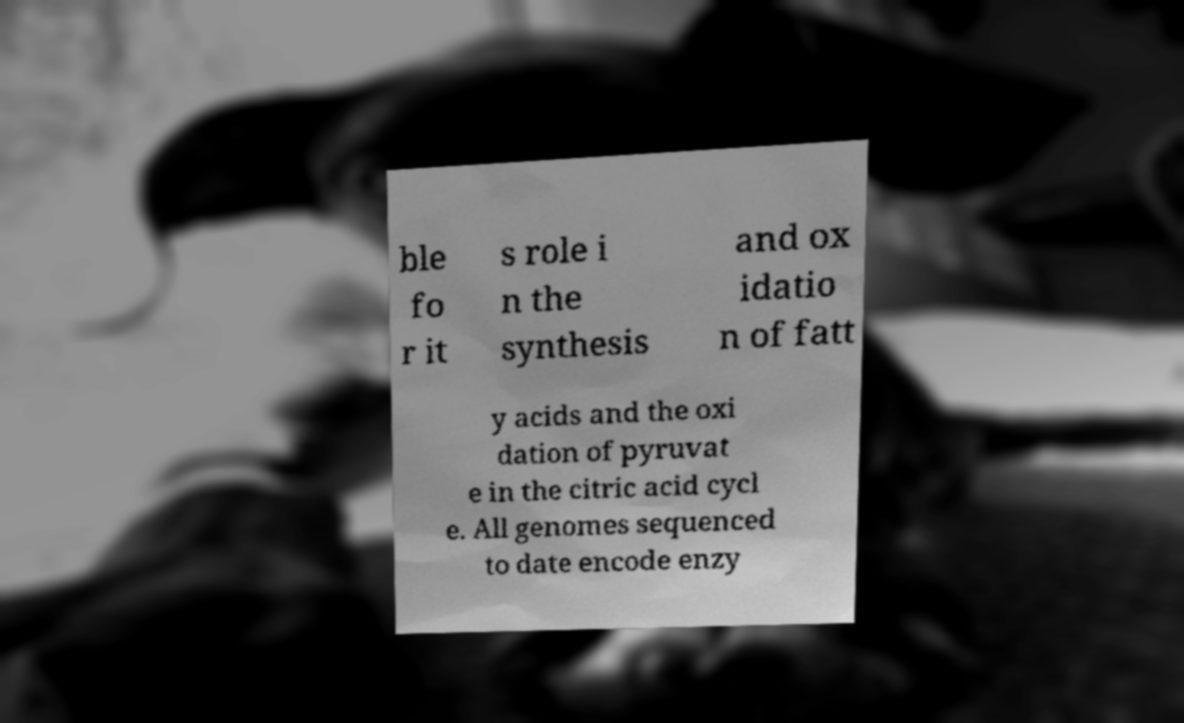Please identify and transcribe the text found in this image. ble fo r it s role i n the synthesis and ox idatio n of fatt y acids and the oxi dation of pyruvat e in the citric acid cycl e. All genomes sequenced to date encode enzy 